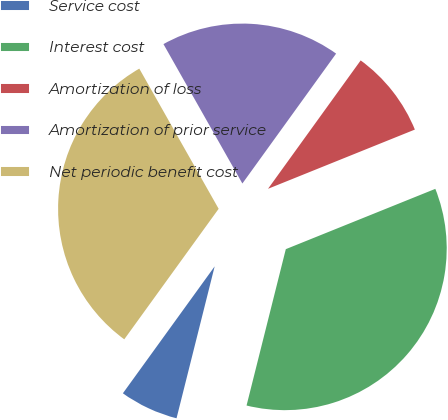<chart> <loc_0><loc_0><loc_500><loc_500><pie_chart><fcel>Service cost<fcel>Interest cost<fcel>Amortization of loss<fcel>Amortization of prior service<fcel>Net periodic benefit cost<nl><fcel>6.05%<fcel>35.02%<fcel>8.95%<fcel>18.15%<fcel>31.84%<nl></chart> 